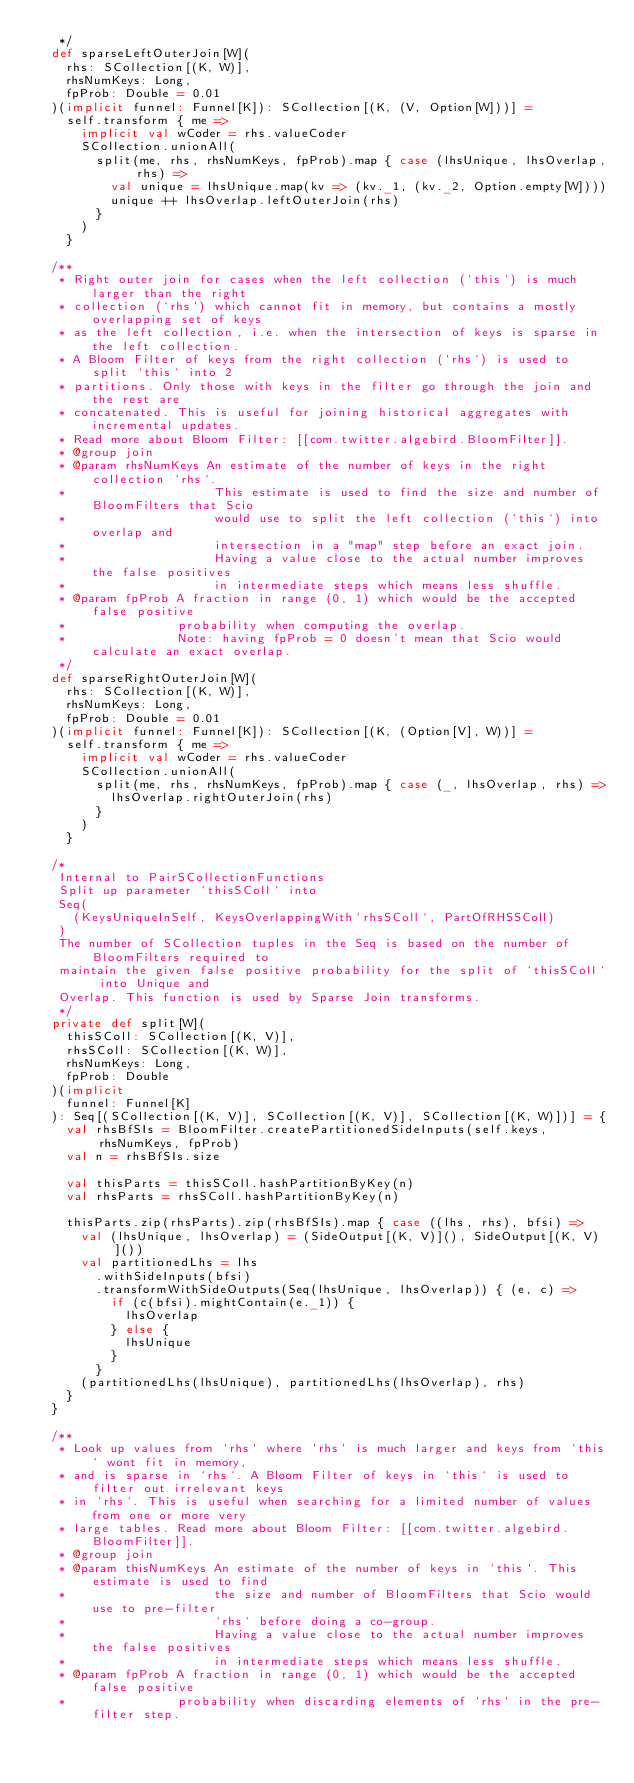<code> <loc_0><loc_0><loc_500><loc_500><_Scala_>   */
  def sparseLeftOuterJoin[W](
    rhs: SCollection[(K, W)],
    rhsNumKeys: Long,
    fpProb: Double = 0.01
  )(implicit funnel: Funnel[K]): SCollection[(K, (V, Option[W]))] =
    self.transform { me =>
      implicit val wCoder = rhs.valueCoder
      SCollection.unionAll(
        split(me, rhs, rhsNumKeys, fpProb).map { case (lhsUnique, lhsOverlap, rhs) =>
          val unique = lhsUnique.map(kv => (kv._1, (kv._2, Option.empty[W])))
          unique ++ lhsOverlap.leftOuterJoin(rhs)
        }
      )
    }

  /**
   * Right outer join for cases when the left collection (`this`) is much larger than the right
   * collection (`rhs`) which cannot fit in memory, but contains a mostly overlapping set of keys
   * as the left collection, i.e. when the intersection of keys is sparse in the left collection.
   * A Bloom Filter of keys from the right collection (`rhs`) is used to split `this` into 2
   * partitions. Only those with keys in the filter go through the join and the rest are
   * concatenated. This is useful for joining historical aggregates with incremental updates.
   * Read more about Bloom Filter: [[com.twitter.algebird.BloomFilter]].
   * @group join
   * @param rhsNumKeys An estimate of the number of keys in the right collection `rhs`.
   *                    This estimate is used to find the size and number of BloomFilters that Scio
   *                    would use to split the left collection (`this`) into overlap and
   *                    intersection in a "map" step before an exact join.
   *                    Having a value close to the actual number improves the false positives
   *                    in intermediate steps which means less shuffle.
   * @param fpProb A fraction in range (0, 1) which would be the accepted false positive
   *               probability when computing the overlap.
   *               Note: having fpProb = 0 doesn't mean that Scio would calculate an exact overlap.
   */
  def sparseRightOuterJoin[W](
    rhs: SCollection[(K, W)],
    rhsNumKeys: Long,
    fpProb: Double = 0.01
  )(implicit funnel: Funnel[K]): SCollection[(K, (Option[V], W))] =
    self.transform { me =>
      implicit val wCoder = rhs.valueCoder
      SCollection.unionAll(
        split(me, rhs, rhsNumKeys, fpProb).map { case (_, lhsOverlap, rhs) =>
          lhsOverlap.rightOuterJoin(rhs)
        }
      )
    }

  /*
   Internal to PairSCollectionFunctions
   Split up parameter `thisSColl` into
   Seq(
     (KeysUniqueInSelf, KeysOverlappingWith`rhsSColl`, PartOfRHSSColl)
   )
   The number of SCollection tuples in the Seq is based on the number of BloomFilters required to
   maintain the given false positive probability for the split of `thisSColl` into Unique and
   Overlap. This function is used by Sparse Join transforms.
   */
  private def split[W](
    thisSColl: SCollection[(K, V)],
    rhsSColl: SCollection[(K, W)],
    rhsNumKeys: Long,
    fpProb: Double
  )(implicit
    funnel: Funnel[K]
  ): Seq[(SCollection[(K, V)], SCollection[(K, V)], SCollection[(K, W)])] = {
    val rhsBfSIs = BloomFilter.createPartitionedSideInputs(self.keys, rhsNumKeys, fpProb)
    val n = rhsBfSIs.size

    val thisParts = thisSColl.hashPartitionByKey(n)
    val rhsParts = rhsSColl.hashPartitionByKey(n)

    thisParts.zip(rhsParts).zip(rhsBfSIs).map { case ((lhs, rhs), bfsi) =>
      val (lhsUnique, lhsOverlap) = (SideOutput[(K, V)](), SideOutput[(K, V)]())
      val partitionedLhs = lhs
        .withSideInputs(bfsi)
        .transformWithSideOutputs(Seq(lhsUnique, lhsOverlap)) { (e, c) =>
          if (c(bfsi).mightContain(e._1)) {
            lhsOverlap
          } else {
            lhsUnique
          }
        }
      (partitionedLhs(lhsUnique), partitionedLhs(lhsOverlap), rhs)
    }
  }

  /**
   * Look up values from `rhs` where `rhs` is much larger and keys from `this` wont fit in memory,
   * and is sparse in `rhs`. A Bloom Filter of keys in `this` is used to filter out irrelevant keys
   * in `rhs`. This is useful when searching for a limited number of values from one or more very
   * large tables. Read more about Bloom Filter: [[com.twitter.algebird.BloomFilter]].
   * @group join
   * @param thisNumKeys An estimate of the number of keys in `this`. This estimate is used to find
   *                    the size and number of BloomFilters that Scio would use to pre-filter
   *                    `rhs` before doing a co-group.
   *                    Having a value close to the actual number improves the false positives
   *                    in intermediate steps which means less shuffle.
   * @param fpProb A fraction in range (0, 1) which would be the accepted false positive
   *               probability when discarding elements of `rhs` in the pre-filter step.</code> 